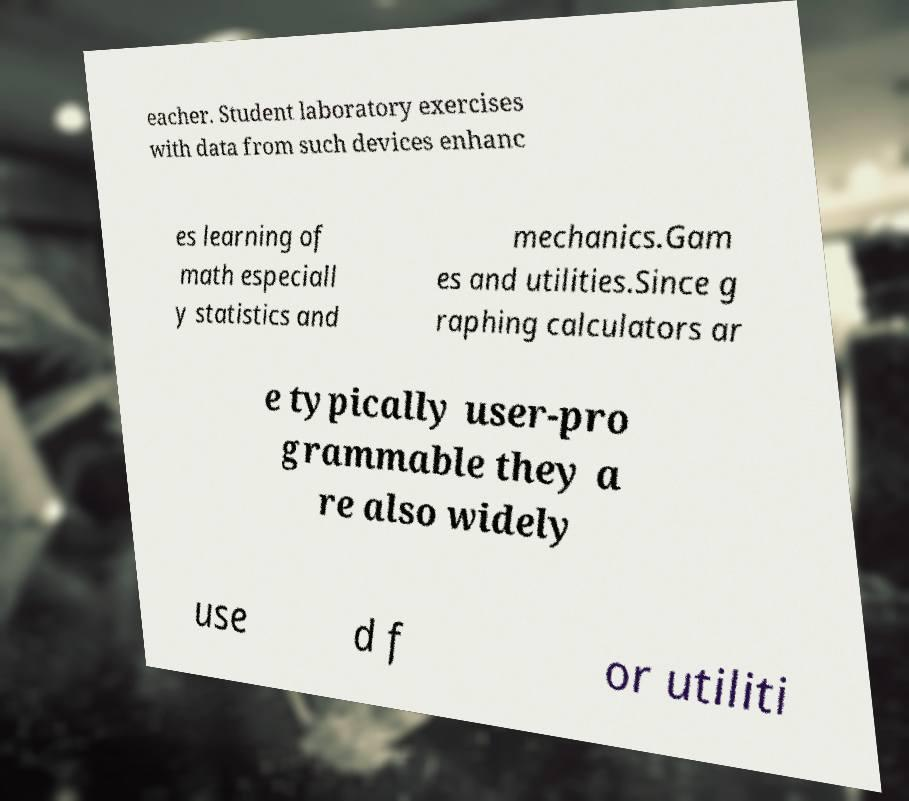For documentation purposes, I need the text within this image transcribed. Could you provide that? eacher. Student laboratory exercises with data from such devices enhanc es learning of math especiall y statistics and mechanics.Gam es and utilities.Since g raphing calculators ar e typically user-pro grammable they a re also widely use d f or utiliti 